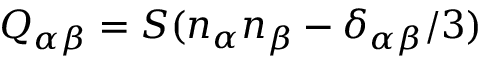<formula> <loc_0><loc_0><loc_500><loc_500>Q _ { \alpha \beta } = S ( n _ { \alpha } n _ { \beta } - \delta _ { \alpha \beta } / 3 )</formula> 